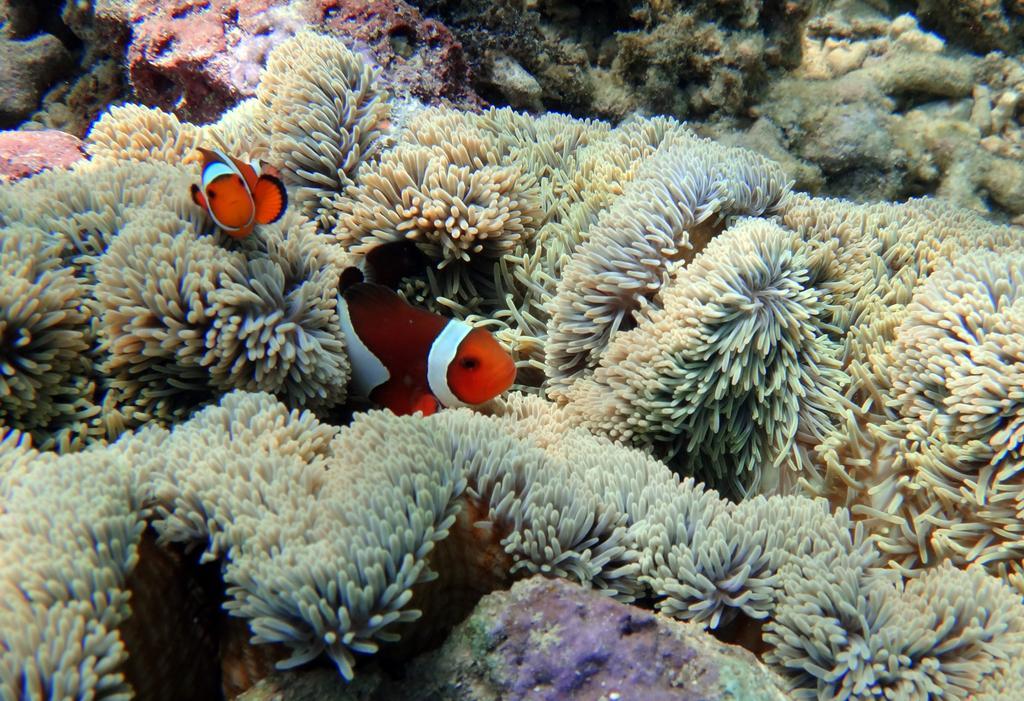How would you summarize this image in a sentence or two? In this picture there are fishes in the water and the fishes are in orange and white color. At the bottom there are marine plants and there is a rock. 